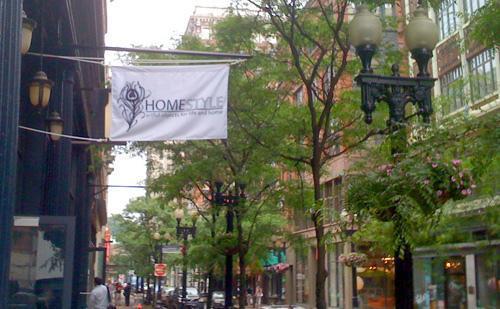How many do not enter signs are visible?
Give a very brief answer. 1. 